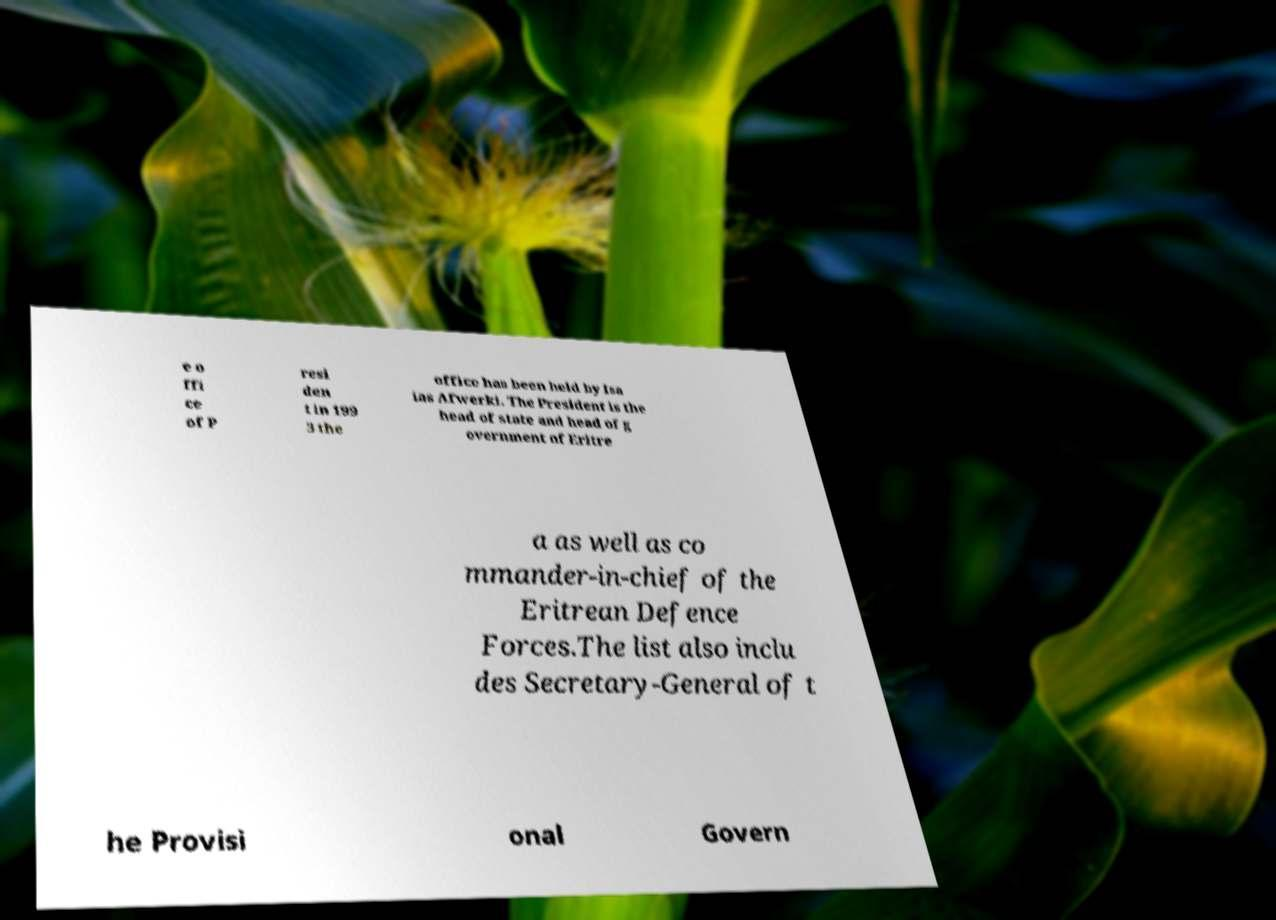Please identify and transcribe the text found in this image. e o ffi ce of P resi den t in 199 3 the office has been held by Isa ias Afwerki. The President is the head of state and head of g overnment of Eritre a as well as co mmander-in-chief of the Eritrean Defence Forces.The list also inclu des Secretary-General of t he Provisi onal Govern 